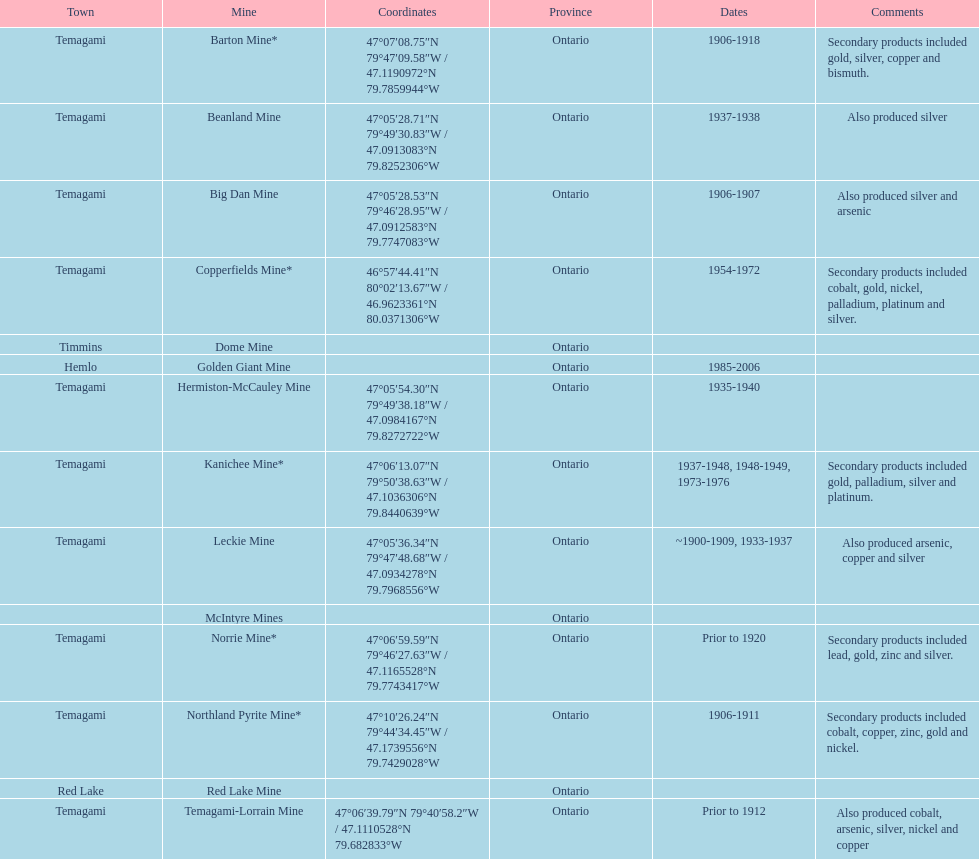What town is cited the most? Temagami. 